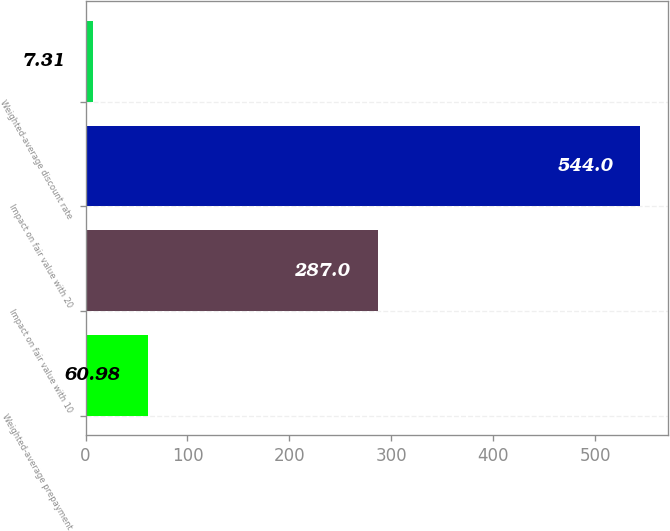Convert chart. <chart><loc_0><loc_0><loc_500><loc_500><bar_chart><fcel>Weighted-average prepayment<fcel>Impact on fair value with 10<fcel>Impact on fair value with 20<fcel>Weighted-average discount rate<nl><fcel>60.98<fcel>287<fcel>544<fcel>7.31<nl></chart> 